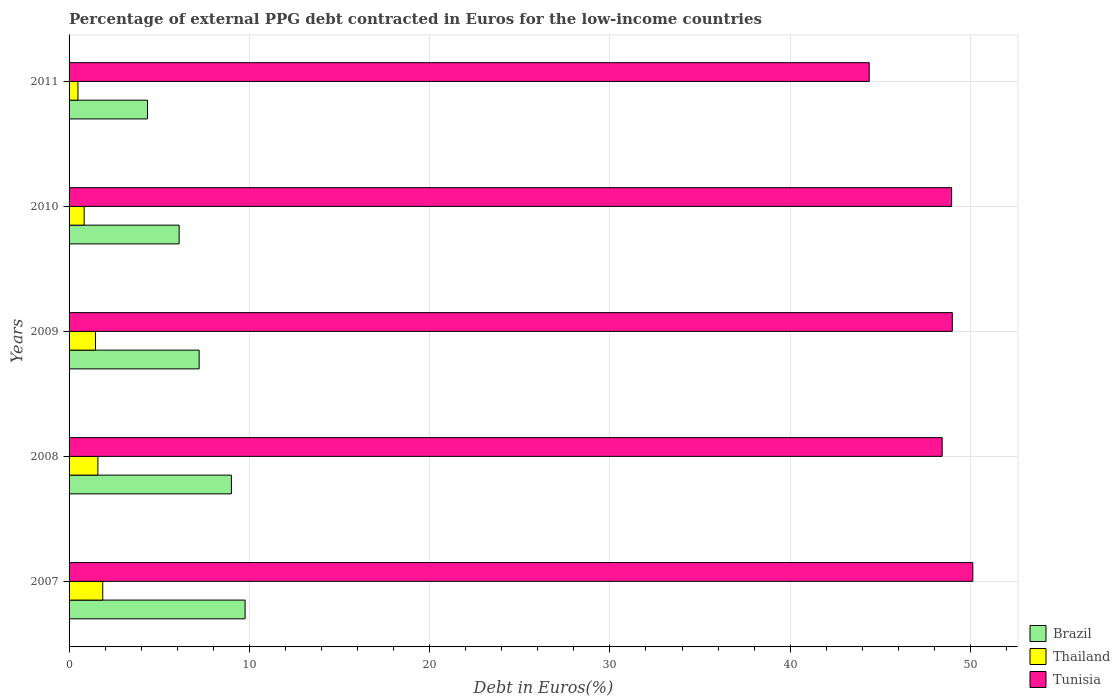How many groups of bars are there?
Offer a terse response. 5. How many bars are there on the 1st tick from the top?
Ensure brevity in your answer.  3. What is the label of the 5th group of bars from the top?
Offer a terse response. 2007. What is the percentage of external PPG debt contracted in Euros in Tunisia in 2007?
Offer a very short reply. 50.13. Across all years, what is the maximum percentage of external PPG debt contracted in Euros in Thailand?
Your response must be concise. 1.87. Across all years, what is the minimum percentage of external PPG debt contracted in Euros in Thailand?
Your response must be concise. 0.49. In which year was the percentage of external PPG debt contracted in Euros in Tunisia minimum?
Ensure brevity in your answer.  2011. What is the total percentage of external PPG debt contracted in Euros in Tunisia in the graph?
Offer a terse response. 240.9. What is the difference between the percentage of external PPG debt contracted in Euros in Thailand in 2007 and that in 2011?
Provide a succinct answer. 1.38. What is the difference between the percentage of external PPG debt contracted in Euros in Thailand in 2009 and the percentage of external PPG debt contracted in Euros in Tunisia in 2007?
Provide a succinct answer. -48.66. What is the average percentage of external PPG debt contracted in Euros in Tunisia per year?
Offer a very short reply. 48.18. In the year 2009, what is the difference between the percentage of external PPG debt contracted in Euros in Tunisia and percentage of external PPG debt contracted in Euros in Thailand?
Make the answer very short. 47.53. In how many years, is the percentage of external PPG debt contracted in Euros in Tunisia greater than 26 %?
Offer a very short reply. 5. What is the ratio of the percentage of external PPG debt contracted in Euros in Thailand in 2008 to that in 2010?
Make the answer very short. 1.91. Is the difference between the percentage of external PPG debt contracted in Euros in Tunisia in 2009 and 2011 greater than the difference between the percentage of external PPG debt contracted in Euros in Thailand in 2009 and 2011?
Provide a succinct answer. Yes. What is the difference between the highest and the second highest percentage of external PPG debt contracted in Euros in Tunisia?
Your response must be concise. 1.14. What is the difference between the highest and the lowest percentage of external PPG debt contracted in Euros in Tunisia?
Your answer should be very brief. 5.75. What does the 3rd bar from the top in 2009 represents?
Your response must be concise. Brazil. What does the 2nd bar from the bottom in 2010 represents?
Keep it short and to the point. Thailand. Is it the case that in every year, the sum of the percentage of external PPG debt contracted in Euros in Tunisia and percentage of external PPG debt contracted in Euros in Brazil is greater than the percentage of external PPG debt contracted in Euros in Thailand?
Your response must be concise. Yes. How many bars are there?
Provide a succinct answer. 15. Are all the bars in the graph horizontal?
Provide a short and direct response. Yes. Are the values on the major ticks of X-axis written in scientific E-notation?
Provide a short and direct response. No. Does the graph contain any zero values?
Ensure brevity in your answer.  No. Does the graph contain grids?
Your response must be concise. Yes. How are the legend labels stacked?
Make the answer very short. Vertical. What is the title of the graph?
Your answer should be very brief. Percentage of external PPG debt contracted in Euros for the low-income countries. Does "Tonga" appear as one of the legend labels in the graph?
Provide a succinct answer. No. What is the label or title of the X-axis?
Provide a succinct answer. Debt in Euros(%). What is the label or title of the Y-axis?
Your response must be concise. Years. What is the Debt in Euros(%) in Brazil in 2007?
Your response must be concise. 9.76. What is the Debt in Euros(%) in Thailand in 2007?
Keep it short and to the point. 1.87. What is the Debt in Euros(%) in Tunisia in 2007?
Your answer should be very brief. 50.13. What is the Debt in Euros(%) of Brazil in 2008?
Keep it short and to the point. 9. What is the Debt in Euros(%) in Thailand in 2008?
Provide a short and direct response. 1.6. What is the Debt in Euros(%) in Tunisia in 2008?
Offer a very short reply. 48.43. What is the Debt in Euros(%) of Brazil in 2009?
Offer a very short reply. 7.22. What is the Debt in Euros(%) in Thailand in 2009?
Your answer should be compact. 1.47. What is the Debt in Euros(%) in Tunisia in 2009?
Offer a terse response. 48.99. What is the Debt in Euros(%) in Brazil in 2010?
Ensure brevity in your answer.  6.1. What is the Debt in Euros(%) in Thailand in 2010?
Your answer should be very brief. 0.84. What is the Debt in Euros(%) of Tunisia in 2010?
Ensure brevity in your answer.  48.96. What is the Debt in Euros(%) in Brazil in 2011?
Give a very brief answer. 4.35. What is the Debt in Euros(%) in Thailand in 2011?
Your answer should be compact. 0.49. What is the Debt in Euros(%) in Tunisia in 2011?
Your response must be concise. 44.39. Across all years, what is the maximum Debt in Euros(%) of Brazil?
Provide a succinct answer. 9.76. Across all years, what is the maximum Debt in Euros(%) of Thailand?
Your answer should be very brief. 1.87. Across all years, what is the maximum Debt in Euros(%) of Tunisia?
Your answer should be compact. 50.13. Across all years, what is the minimum Debt in Euros(%) in Brazil?
Provide a short and direct response. 4.35. Across all years, what is the minimum Debt in Euros(%) of Thailand?
Offer a terse response. 0.49. Across all years, what is the minimum Debt in Euros(%) of Tunisia?
Your answer should be compact. 44.39. What is the total Debt in Euros(%) of Brazil in the graph?
Give a very brief answer. 36.44. What is the total Debt in Euros(%) of Thailand in the graph?
Offer a very short reply. 6.26. What is the total Debt in Euros(%) in Tunisia in the graph?
Your response must be concise. 240.9. What is the difference between the Debt in Euros(%) in Brazil in 2007 and that in 2008?
Keep it short and to the point. 0.76. What is the difference between the Debt in Euros(%) of Thailand in 2007 and that in 2008?
Make the answer very short. 0.27. What is the difference between the Debt in Euros(%) in Tunisia in 2007 and that in 2008?
Give a very brief answer. 1.7. What is the difference between the Debt in Euros(%) in Brazil in 2007 and that in 2009?
Keep it short and to the point. 2.55. What is the difference between the Debt in Euros(%) in Thailand in 2007 and that in 2009?
Offer a very short reply. 0.4. What is the difference between the Debt in Euros(%) in Tunisia in 2007 and that in 2009?
Provide a short and direct response. 1.14. What is the difference between the Debt in Euros(%) in Brazil in 2007 and that in 2010?
Give a very brief answer. 3.66. What is the difference between the Debt in Euros(%) of Thailand in 2007 and that in 2010?
Provide a short and direct response. 1.03. What is the difference between the Debt in Euros(%) in Tunisia in 2007 and that in 2010?
Your response must be concise. 1.18. What is the difference between the Debt in Euros(%) in Brazil in 2007 and that in 2011?
Provide a succinct answer. 5.41. What is the difference between the Debt in Euros(%) in Thailand in 2007 and that in 2011?
Provide a short and direct response. 1.38. What is the difference between the Debt in Euros(%) in Tunisia in 2007 and that in 2011?
Make the answer very short. 5.75. What is the difference between the Debt in Euros(%) in Brazil in 2008 and that in 2009?
Give a very brief answer. 1.79. What is the difference between the Debt in Euros(%) in Thailand in 2008 and that in 2009?
Your response must be concise. 0.13. What is the difference between the Debt in Euros(%) of Tunisia in 2008 and that in 2009?
Make the answer very short. -0.56. What is the difference between the Debt in Euros(%) in Brazil in 2008 and that in 2010?
Keep it short and to the point. 2.9. What is the difference between the Debt in Euros(%) in Thailand in 2008 and that in 2010?
Make the answer very short. 0.76. What is the difference between the Debt in Euros(%) of Tunisia in 2008 and that in 2010?
Give a very brief answer. -0.52. What is the difference between the Debt in Euros(%) in Brazil in 2008 and that in 2011?
Offer a terse response. 4.65. What is the difference between the Debt in Euros(%) in Thailand in 2008 and that in 2011?
Make the answer very short. 1.1. What is the difference between the Debt in Euros(%) in Tunisia in 2008 and that in 2011?
Your answer should be very brief. 4.05. What is the difference between the Debt in Euros(%) in Brazil in 2009 and that in 2010?
Keep it short and to the point. 1.11. What is the difference between the Debt in Euros(%) of Thailand in 2009 and that in 2010?
Provide a succinct answer. 0.63. What is the difference between the Debt in Euros(%) in Tunisia in 2009 and that in 2010?
Offer a terse response. 0.04. What is the difference between the Debt in Euros(%) of Brazil in 2009 and that in 2011?
Offer a terse response. 2.87. What is the difference between the Debt in Euros(%) of Thailand in 2009 and that in 2011?
Keep it short and to the point. 0.97. What is the difference between the Debt in Euros(%) of Tunisia in 2009 and that in 2011?
Make the answer very short. 4.61. What is the difference between the Debt in Euros(%) in Brazil in 2010 and that in 2011?
Keep it short and to the point. 1.76. What is the difference between the Debt in Euros(%) in Thailand in 2010 and that in 2011?
Offer a terse response. 0.34. What is the difference between the Debt in Euros(%) in Tunisia in 2010 and that in 2011?
Provide a short and direct response. 4.57. What is the difference between the Debt in Euros(%) of Brazil in 2007 and the Debt in Euros(%) of Thailand in 2008?
Your response must be concise. 8.17. What is the difference between the Debt in Euros(%) of Brazil in 2007 and the Debt in Euros(%) of Tunisia in 2008?
Make the answer very short. -38.67. What is the difference between the Debt in Euros(%) in Thailand in 2007 and the Debt in Euros(%) in Tunisia in 2008?
Your answer should be very brief. -46.56. What is the difference between the Debt in Euros(%) in Brazil in 2007 and the Debt in Euros(%) in Thailand in 2009?
Provide a short and direct response. 8.3. What is the difference between the Debt in Euros(%) in Brazil in 2007 and the Debt in Euros(%) in Tunisia in 2009?
Your response must be concise. -39.23. What is the difference between the Debt in Euros(%) of Thailand in 2007 and the Debt in Euros(%) of Tunisia in 2009?
Offer a terse response. -47.13. What is the difference between the Debt in Euros(%) in Brazil in 2007 and the Debt in Euros(%) in Thailand in 2010?
Offer a very short reply. 8.93. What is the difference between the Debt in Euros(%) in Brazil in 2007 and the Debt in Euros(%) in Tunisia in 2010?
Your response must be concise. -39.19. What is the difference between the Debt in Euros(%) of Thailand in 2007 and the Debt in Euros(%) of Tunisia in 2010?
Your answer should be compact. -47.09. What is the difference between the Debt in Euros(%) of Brazil in 2007 and the Debt in Euros(%) of Thailand in 2011?
Your answer should be compact. 9.27. What is the difference between the Debt in Euros(%) of Brazil in 2007 and the Debt in Euros(%) of Tunisia in 2011?
Provide a short and direct response. -34.62. What is the difference between the Debt in Euros(%) of Thailand in 2007 and the Debt in Euros(%) of Tunisia in 2011?
Your answer should be very brief. -42.52. What is the difference between the Debt in Euros(%) in Brazil in 2008 and the Debt in Euros(%) in Thailand in 2009?
Provide a short and direct response. 7.54. What is the difference between the Debt in Euros(%) of Brazil in 2008 and the Debt in Euros(%) of Tunisia in 2009?
Your response must be concise. -39.99. What is the difference between the Debt in Euros(%) of Thailand in 2008 and the Debt in Euros(%) of Tunisia in 2009?
Make the answer very short. -47.4. What is the difference between the Debt in Euros(%) of Brazil in 2008 and the Debt in Euros(%) of Thailand in 2010?
Your response must be concise. 8.17. What is the difference between the Debt in Euros(%) of Brazil in 2008 and the Debt in Euros(%) of Tunisia in 2010?
Your answer should be very brief. -39.95. What is the difference between the Debt in Euros(%) in Thailand in 2008 and the Debt in Euros(%) in Tunisia in 2010?
Make the answer very short. -47.36. What is the difference between the Debt in Euros(%) of Brazil in 2008 and the Debt in Euros(%) of Thailand in 2011?
Keep it short and to the point. 8.51. What is the difference between the Debt in Euros(%) in Brazil in 2008 and the Debt in Euros(%) in Tunisia in 2011?
Offer a terse response. -35.38. What is the difference between the Debt in Euros(%) of Thailand in 2008 and the Debt in Euros(%) of Tunisia in 2011?
Give a very brief answer. -42.79. What is the difference between the Debt in Euros(%) of Brazil in 2009 and the Debt in Euros(%) of Thailand in 2010?
Provide a short and direct response. 6.38. What is the difference between the Debt in Euros(%) in Brazil in 2009 and the Debt in Euros(%) in Tunisia in 2010?
Keep it short and to the point. -41.74. What is the difference between the Debt in Euros(%) of Thailand in 2009 and the Debt in Euros(%) of Tunisia in 2010?
Your response must be concise. -47.49. What is the difference between the Debt in Euros(%) in Brazil in 2009 and the Debt in Euros(%) in Thailand in 2011?
Make the answer very short. 6.72. What is the difference between the Debt in Euros(%) in Brazil in 2009 and the Debt in Euros(%) in Tunisia in 2011?
Provide a succinct answer. -37.17. What is the difference between the Debt in Euros(%) of Thailand in 2009 and the Debt in Euros(%) of Tunisia in 2011?
Give a very brief answer. -42.92. What is the difference between the Debt in Euros(%) in Brazil in 2010 and the Debt in Euros(%) in Thailand in 2011?
Keep it short and to the point. 5.61. What is the difference between the Debt in Euros(%) in Brazil in 2010 and the Debt in Euros(%) in Tunisia in 2011?
Your answer should be very brief. -38.28. What is the difference between the Debt in Euros(%) in Thailand in 2010 and the Debt in Euros(%) in Tunisia in 2011?
Your answer should be compact. -43.55. What is the average Debt in Euros(%) in Brazil per year?
Your response must be concise. 7.29. What is the average Debt in Euros(%) of Thailand per year?
Provide a succinct answer. 1.25. What is the average Debt in Euros(%) of Tunisia per year?
Make the answer very short. 48.18. In the year 2007, what is the difference between the Debt in Euros(%) in Brazil and Debt in Euros(%) in Thailand?
Keep it short and to the point. 7.9. In the year 2007, what is the difference between the Debt in Euros(%) in Brazil and Debt in Euros(%) in Tunisia?
Offer a terse response. -40.37. In the year 2007, what is the difference between the Debt in Euros(%) of Thailand and Debt in Euros(%) of Tunisia?
Your answer should be compact. -48.26. In the year 2008, what is the difference between the Debt in Euros(%) in Brazil and Debt in Euros(%) in Thailand?
Your response must be concise. 7.41. In the year 2008, what is the difference between the Debt in Euros(%) of Brazil and Debt in Euros(%) of Tunisia?
Your response must be concise. -39.43. In the year 2008, what is the difference between the Debt in Euros(%) in Thailand and Debt in Euros(%) in Tunisia?
Your answer should be compact. -46.83. In the year 2009, what is the difference between the Debt in Euros(%) in Brazil and Debt in Euros(%) in Thailand?
Ensure brevity in your answer.  5.75. In the year 2009, what is the difference between the Debt in Euros(%) of Brazil and Debt in Euros(%) of Tunisia?
Your answer should be compact. -41.78. In the year 2009, what is the difference between the Debt in Euros(%) of Thailand and Debt in Euros(%) of Tunisia?
Ensure brevity in your answer.  -47.53. In the year 2010, what is the difference between the Debt in Euros(%) in Brazil and Debt in Euros(%) in Thailand?
Keep it short and to the point. 5.27. In the year 2010, what is the difference between the Debt in Euros(%) in Brazil and Debt in Euros(%) in Tunisia?
Keep it short and to the point. -42.85. In the year 2010, what is the difference between the Debt in Euros(%) of Thailand and Debt in Euros(%) of Tunisia?
Make the answer very short. -48.12. In the year 2011, what is the difference between the Debt in Euros(%) of Brazil and Debt in Euros(%) of Thailand?
Ensure brevity in your answer.  3.86. In the year 2011, what is the difference between the Debt in Euros(%) in Brazil and Debt in Euros(%) in Tunisia?
Your answer should be compact. -40.04. In the year 2011, what is the difference between the Debt in Euros(%) in Thailand and Debt in Euros(%) in Tunisia?
Your answer should be very brief. -43.89. What is the ratio of the Debt in Euros(%) in Brazil in 2007 to that in 2008?
Provide a succinct answer. 1.08. What is the ratio of the Debt in Euros(%) in Thailand in 2007 to that in 2008?
Offer a very short reply. 1.17. What is the ratio of the Debt in Euros(%) of Tunisia in 2007 to that in 2008?
Give a very brief answer. 1.04. What is the ratio of the Debt in Euros(%) in Brazil in 2007 to that in 2009?
Provide a short and direct response. 1.35. What is the ratio of the Debt in Euros(%) of Thailand in 2007 to that in 2009?
Provide a succinct answer. 1.27. What is the ratio of the Debt in Euros(%) in Tunisia in 2007 to that in 2009?
Your response must be concise. 1.02. What is the ratio of the Debt in Euros(%) of Brazil in 2007 to that in 2010?
Your response must be concise. 1.6. What is the ratio of the Debt in Euros(%) in Thailand in 2007 to that in 2010?
Keep it short and to the point. 2.23. What is the ratio of the Debt in Euros(%) in Tunisia in 2007 to that in 2010?
Provide a succinct answer. 1.02. What is the ratio of the Debt in Euros(%) in Brazil in 2007 to that in 2011?
Give a very brief answer. 2.25. What is the ratio of the Debt in Euros(%) in Thailand in 2007 to that in 2011?
Offer a terse response. 3.79. What is the ratio of the Debt in Euros(%) of Tunisia in 2007 to that in 2011?
Your answer should be very brief. 1.13. What is the ratio of the Debt in Euros(%) in Brazil in 2008 to that in 2009?
Your response must be concise. 1.25. What is the ratio of the Debt in Euros(%) of Thailand in 2008 to that in 2009?
Ensure brevity in your answer.  1.09. What is the ratio of the Debt in Euros(%) of Tunisia in 2008 to that in 2009?
Offer a very short reply. 0.99. What is the ratio of the Debt in Euros(%) in Brazil in 2008 to that in 2010?
Offer a terse response. 1.48. What is the ratio of the Debt in Euros(%) of Thailand in 2008 to that in 2010?
Offer a terse response. 1.91. What is the ratio of the Debt in Euros(%) of Tunisia in 2008 to that in 2010?
Give a very brief answer. 0.99. What is the ratio of the Debt in Euros(%) in Brazil in 2008 to that in 2011?
Provide a succinct answer. 2.07. What is the ratio of the Debt in Euros(%) of Thailand in 2008 to that in 2011?
Your answer should be compact. 3.24. What is the ratio of the Debt in Euros(%) in Tunisia in 2008 to that in 2011?
Provide a short and direct response. 1.09. What is the ratio of the Debt in Euros(%) in Brazil in 2009 to that in 2010?
Ensure brevity in your answer.  1.18. What is the ratio of the Debt in Euros(%) in Thailand in 2009 to that in 2010?
Give a very brief answer. 1.75. What is the ratio of the Debt in Euros(%) of Brazil in 2009 to that in 2011?
Offer a very short reply. 1.66. What is the ratio of the Debt in Euros(%) in Thailand in 2009 to that in 2011?
Your answer should be compact. 2.98. What is the ratio of the Debt in Euros(%) in Tunisia in 2009 to that in 2011?
Offer a terse response. 1.1. What is the ratio of the Debt in Euros(%) of Brazil in 2010 to that in 2011?
Your answer should be very brief. 1.4. What is the ratio of the Debt in Euros(%) of Thailand in 2010 to that in 2011?
Your answer should be compact. 1.7. What is the ratio of the Debt in Euros(%) in Tunisia in 2010 to that in 2011?
Offer a terse response. 1.1. What is the difference between the highest and the second highest Debt in Euros(%) of Brazil?
Offer a terse response. 0.76. What is the difference between the highest and the second highest Debt in Euros(%) of Thailand?
Your response must be concise. 0.27. What is the difference between the highest and the second highest Debt in Euros(%) in Tunisia?
Ensure brevity in your answer.  1.14. What is the difference between the highest and the lowest Debt in Euros(%) in Brazil?
Your response must be concise. 5.41. What is the difference between the highest and the lowest Debt in Euros(%) of Thailand?
Provide a succinct answer. 1.38. What is the difference between the highest and the lowest Debt in Euros(%) in Tunisia?
Keep it short and to the point. 5.75. 